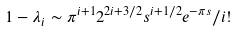<formula> <loc_0><loc_0><loc_500><loc_500>1 - \lambda _ { i } \sim \pi ^ { i + 1 } 2 ^ { 2 i + 3 / 2 } s ^ { i + 1 / 2 } e ^ { - \pi s } / i !</formula> 